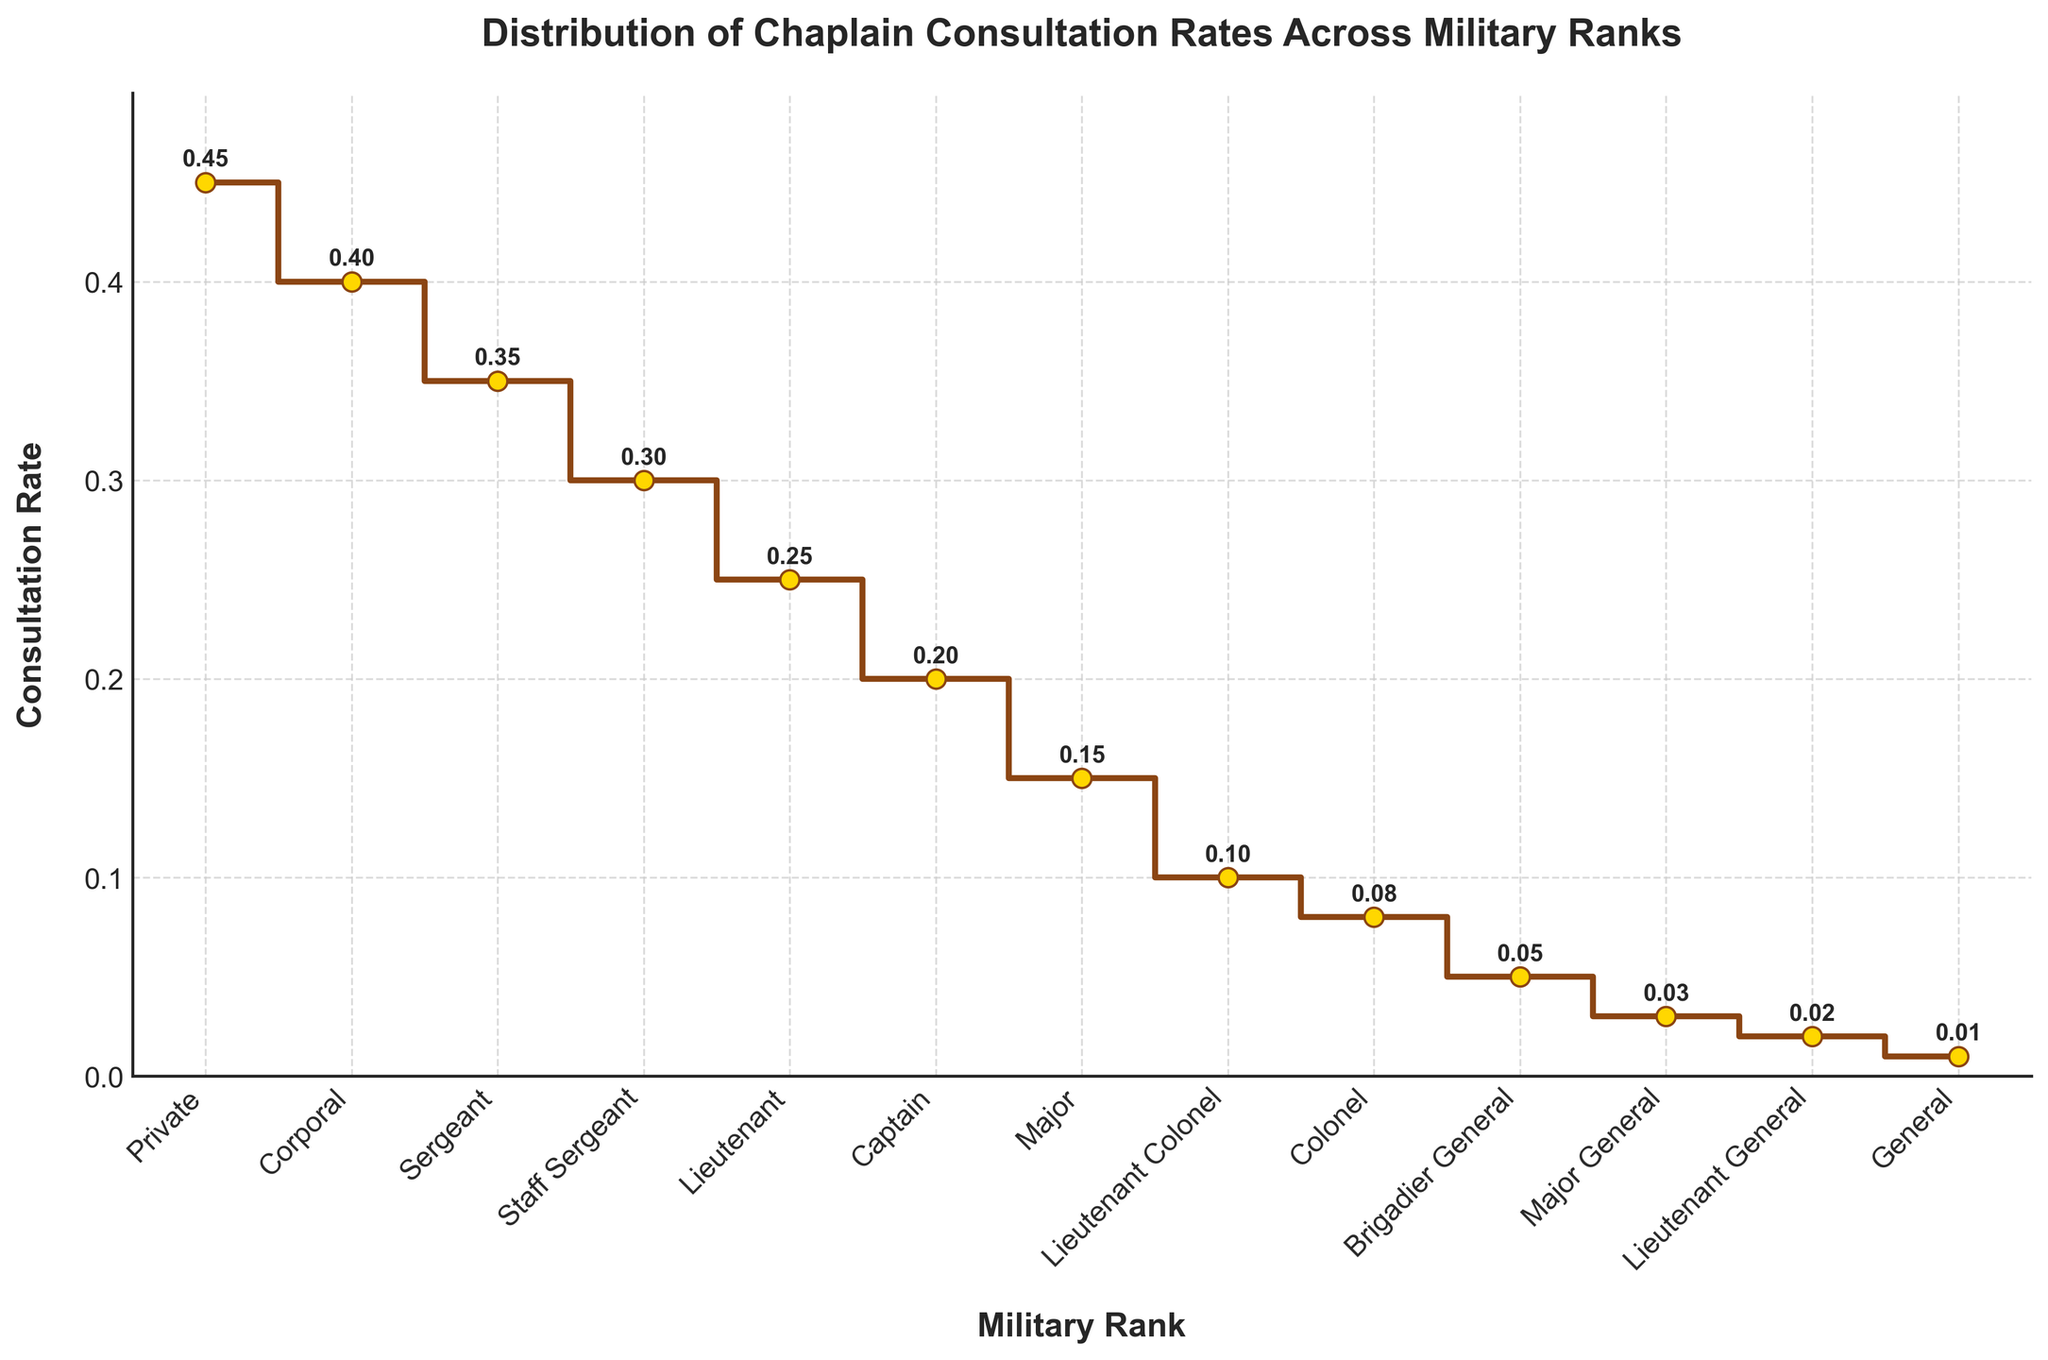What is the title of the figure? The title is displayed at the top of the figure in bold font. It reads "Distribution of Chaplain Consultation Rates Across Military Ranks."
Answer: Distribution of Chaplain Consultation Rates Across Military Ranks What does the y-axis represent? The y-axis is labeled "Consultation Rate" and represents the rate of chaplain consultations.
Answer: Consultation Rate Which rank has the highest consultation rate? By looking at the stair plot, the rank with the highest point on the y-axis is "Private."
Answer: Private What is the consultation rate for Captains? Follow the point corresponding to "Captain" on the x-axis to its value on the y-axis, which is annotated as 0.20.
Answer: 0.20 What rank has the lowest consultation rate? The lowest point on the y-axis corresponds to "General."
Answer: General How many different military ranks are represented in the figure? By counting the points on the x-axis, each labeled with a different military rank, there are 13 ranks.
Answer: 13 What is the difference in consultation rates between Privates and Generals? The consultation rate for Privates is 0.45, and for Generals, it is 0.01. The difference is 0.45 - 0.01.
Answer: 0.44 What is the median consultation rate among the military ranks? Organize the consultation rates in ascending order (0.01, 0.02, 0.03, 0.05, 0.08, 0.10, 0.15, 0.20, 0.25, 0.30, 0.35, 0.40, 0.45). The median is the middle value, which is 0.15 (7th value in an ordered list of 13).
Answer: 0.15 Which rank shows a consultation rate of 0.10? Locate the point on the stair plot where the rate is annotated as 0.10 on the y-axis, which corresponds to "Lieutenant Colonel."
Answer: Lieutenant Colonel What trend can be observed in the consultation rates from lower to higher ranks? By examining the plot from the left (lower ranks) to the right (higher ranks), there is a clear decreasing trend in the consultation rates.
Answer: Decreasing trend 